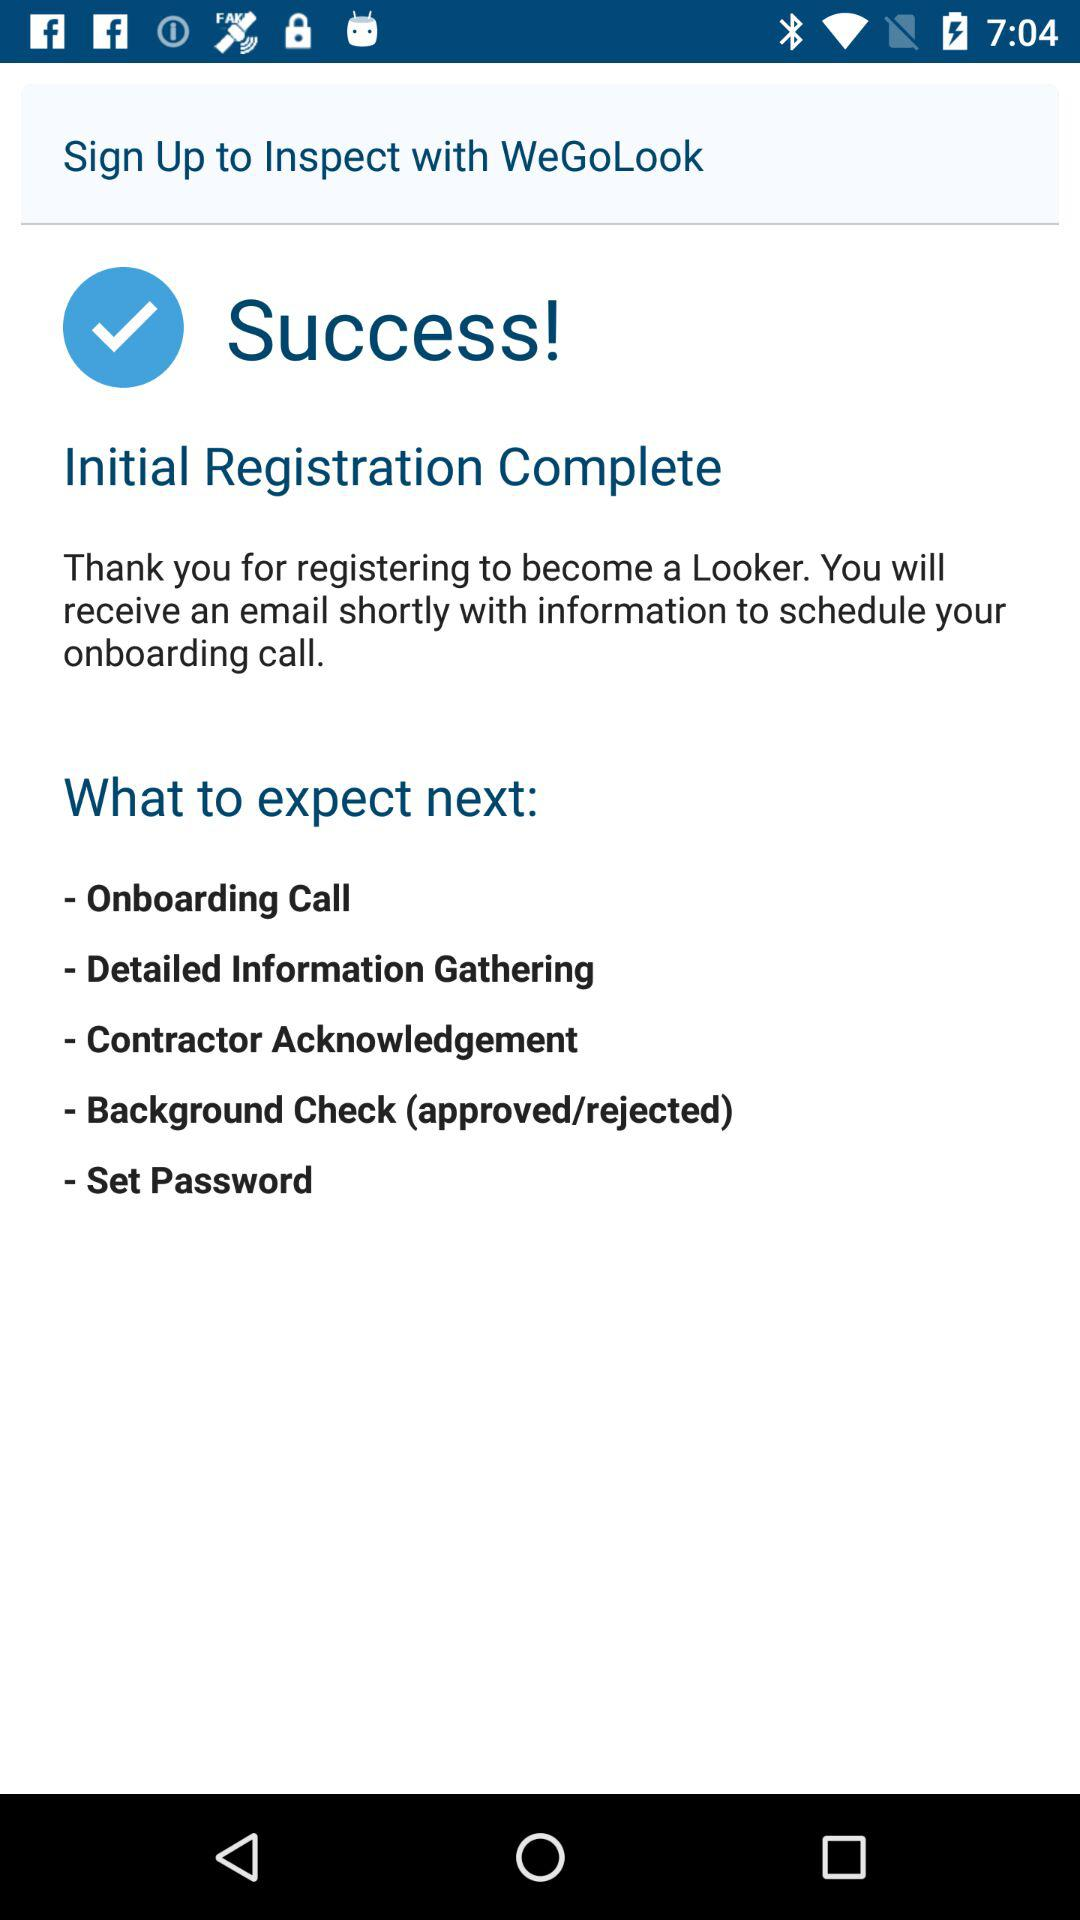How many steps are there before the background check?
Answer the question using a single word or phrase. 3 